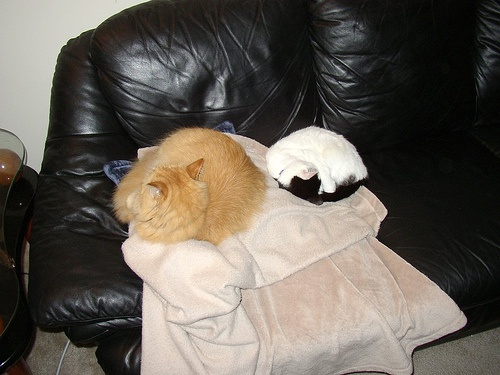Describe the objects in this image and their specific colors. I can see couch in darkgray, black, and gray tones, cat in darkgray, tan, and olive tones, and cat in darkgray, ivory, black, and gray tones in this image. 